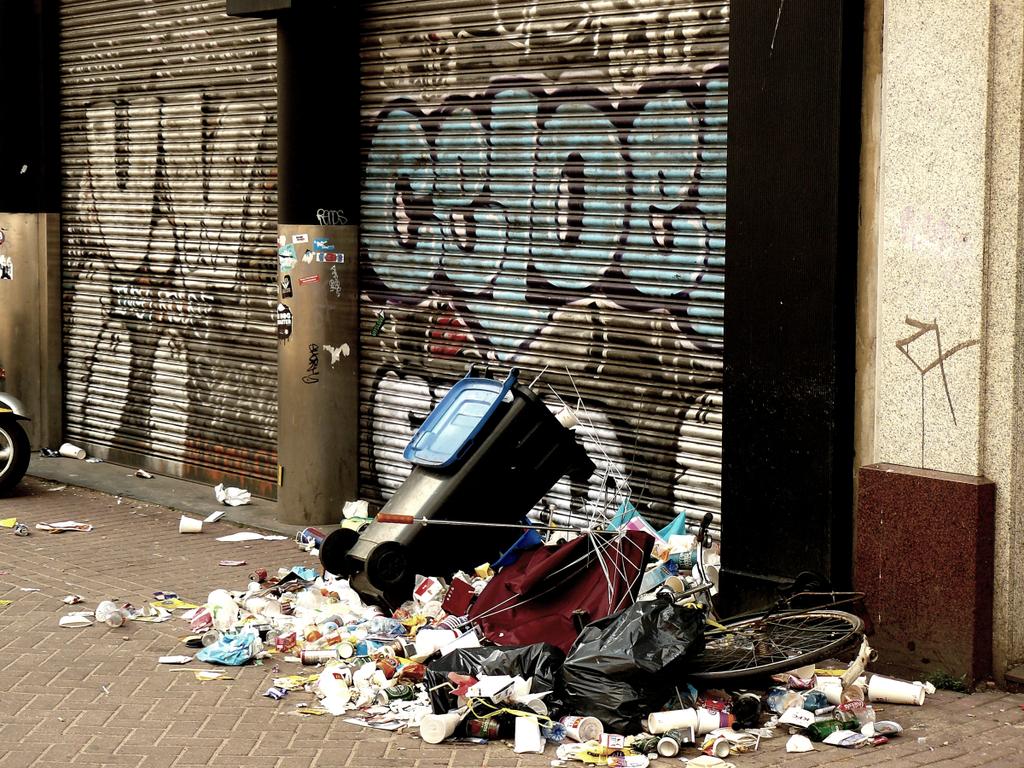Which two letters are painted in white on the left garage door?
Keep it short and to the point. Uv. 